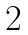Convert formula to latex. <formula><loc_0><loc_0><loc_500><loc_500>\begin{array} { r c r c l } 2 \end{array}</formula> 